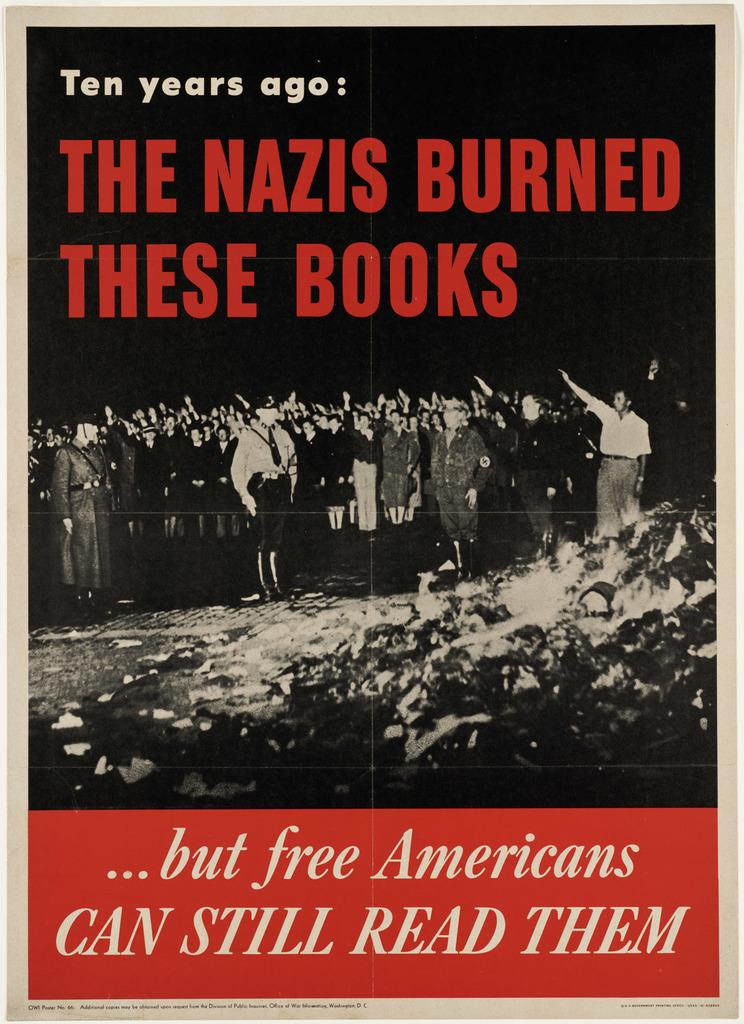<image>
Relay a brief, clear account of the picture shown. A poster references the Nazis burning books in the past. 